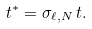<formula> <loc_0><loc_0><loc_500><loc_500>t ^ { \ast } = \sigma _ { \ell , N } \, t .</formula> 